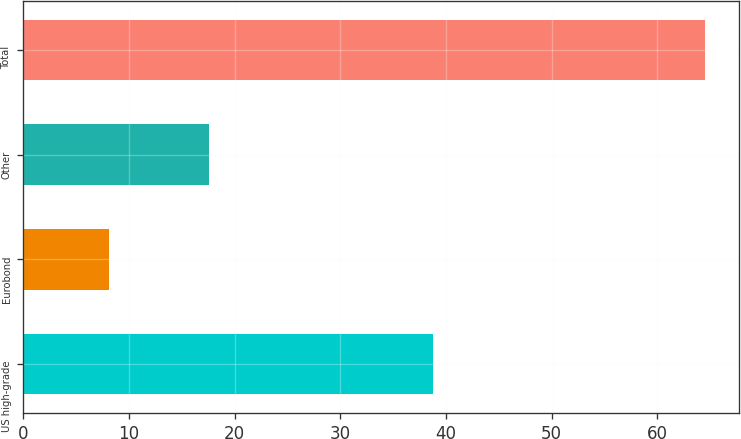Convert chart. <chart><loc_0><loc_0><loc_500><loc_500><bar_chart><fcel>US high-grade<fcel>Eurobond<fcel>Other<fcel>Total<nl><fcel>38.8<fcel>8.1<fcel>17.6<fcel>64.5<nl></chart> 